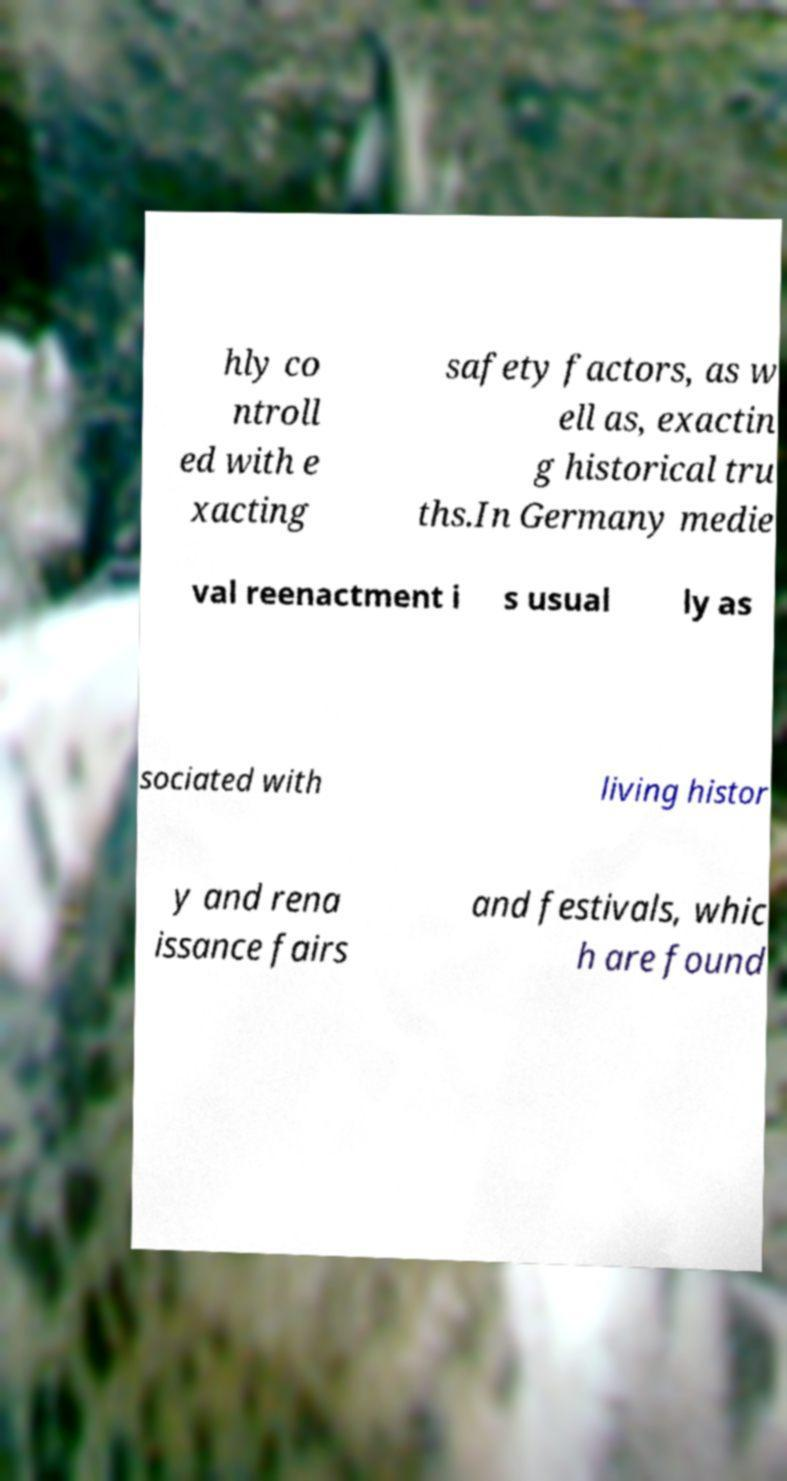Please read and relay the text visible in this image. What does it say? hly co ntroll ed with e xacting safety factors, as w ell as, exactin g historical tru ths.In Germany medie val reenactment i s usual ly as sociated with living histor y and rena issance fairs and festivals, whic h are found 